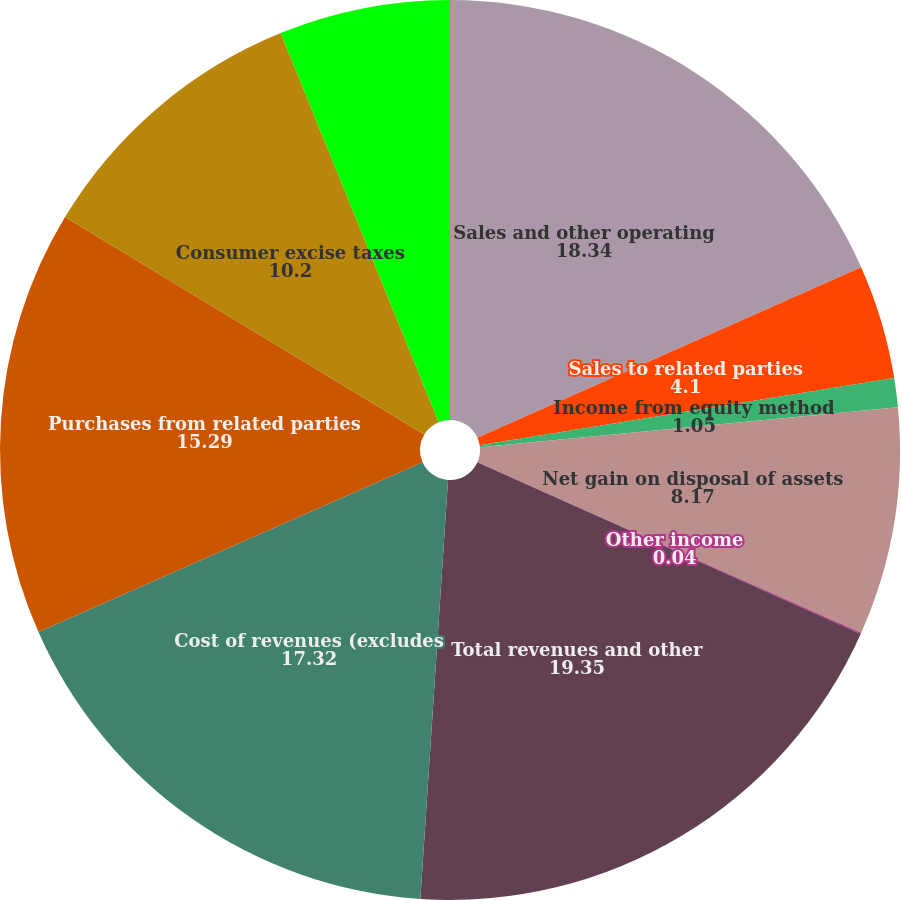Convert chart. <chart><loc_0><loc_0><loc_500><loc_500><pie_chart><fcel>Sales and other operating<fcel>Sales to related parties<fcel>Income from equity method<fcel>Net gain on disposal of assets<fcel>Other income<fcel>Total revenues and other<fcel>Cost of revenues (excludes<fcel>Purchases from related parties<fcel>Consumer excise taxes<fcel>Depreciation and amortization<nl><fcel>18.34%<fcel>4.1%<fcel>1.05%<fcel>8.17%<fcel>0.04%<fcel>19.35%<fcel>17.32%<fcel>15.29%<fcel>10.2%<fcel>6.14%<nl></chart> 